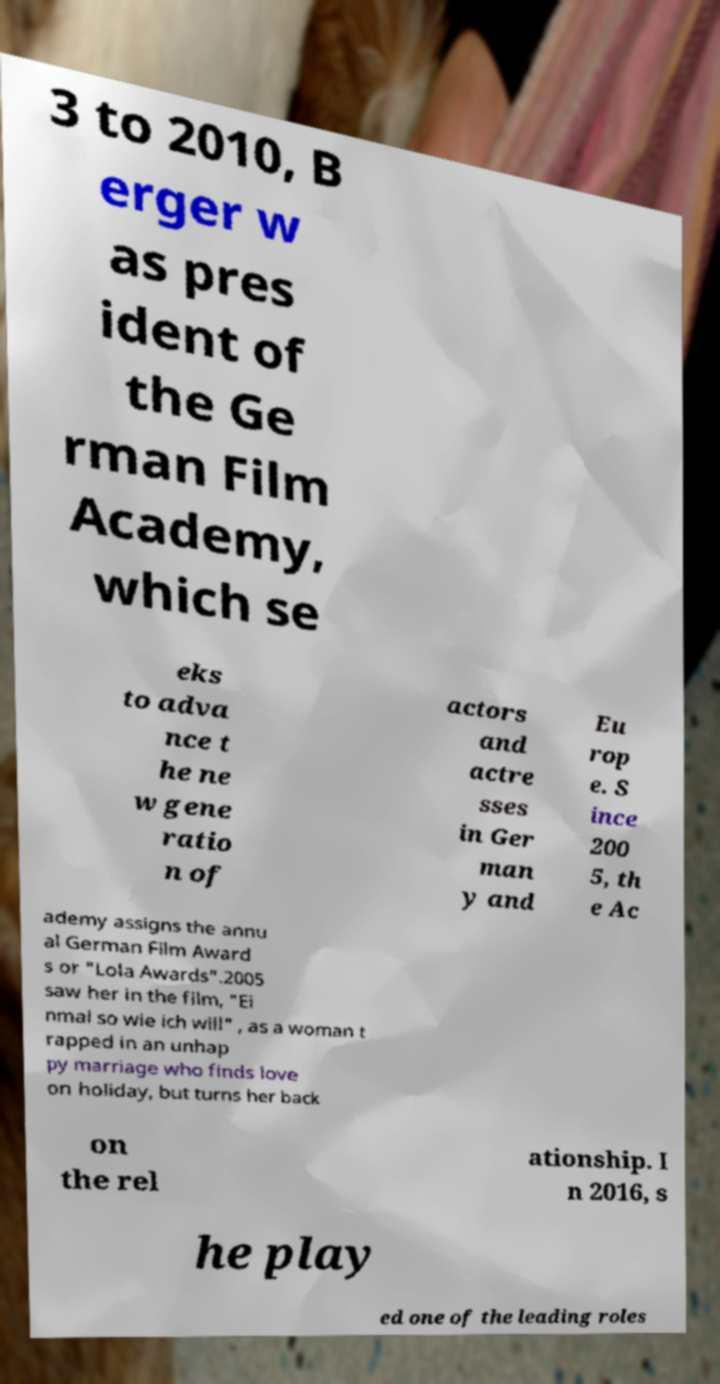Please read and relay the text visible in this image. What does it say? 3 to 2010, B erger w as pres ident of the Ge rman Film Academy, which se eks to adva nce t he ne w gene ratio n of actors and actre sses in Ger man y and Eu rop e. S ince 200 5, th e Ac ademy assigns the annu al German Film Award s or "Lola Awards".2005 saw her in the film, "Ei nmal so wie ich will" , as a woman t rapped in an unhap py marriage who finds love on holiday, but turns her back on the rel ationship. I n 2016, s he play ed one of the leading roles 